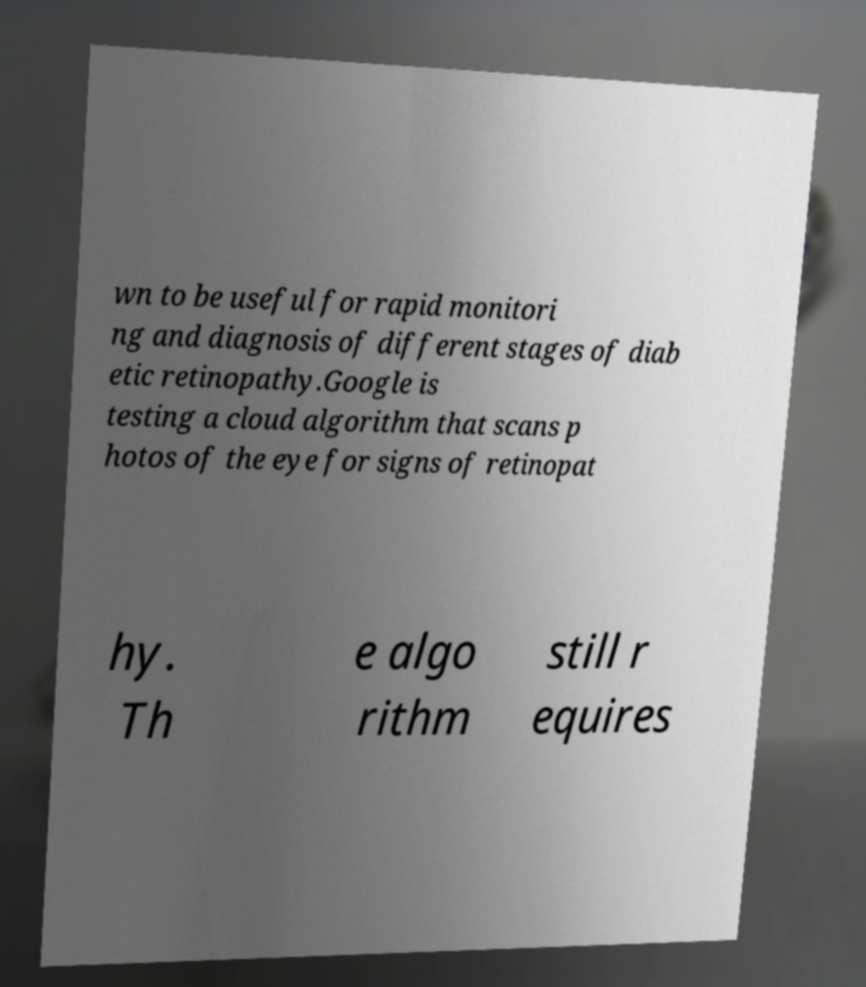Can you accurately transcribe the text from the provided image for me? wn to be useful for rapid monitori ng and diagnosis of different stages of diab etic retinopathy.Google is testing a cloud algorithm that scans p hotos of the eye for signs of retinopat hy. Th e algo rithm still r equires 